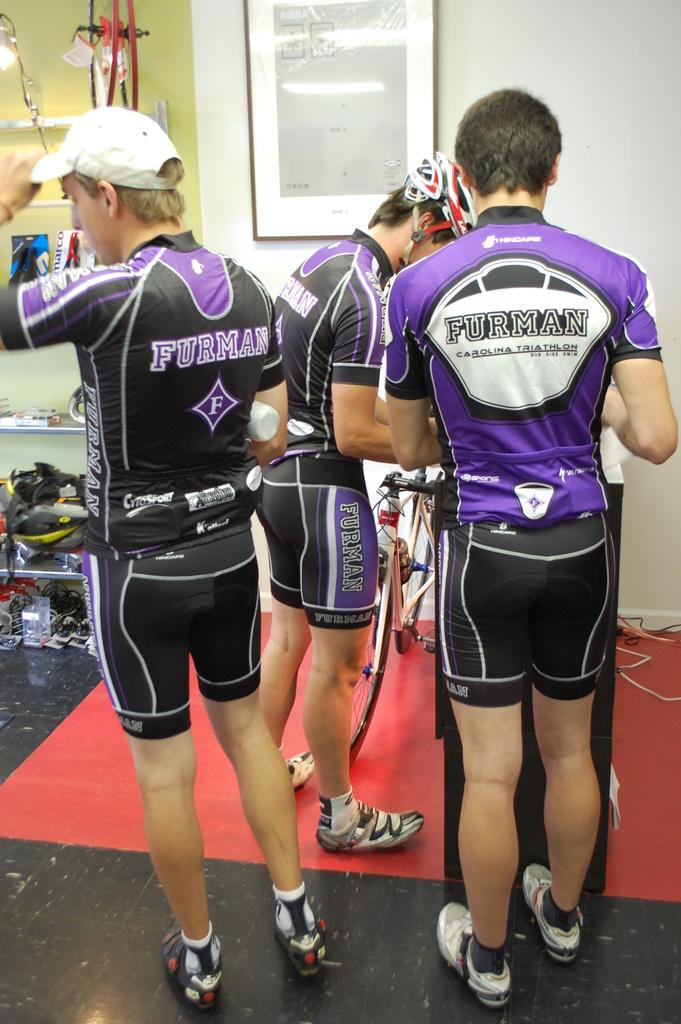<image>
Write a terse but informative summary of the picture. Three men are wearing cycling gear with Furman written on it. 